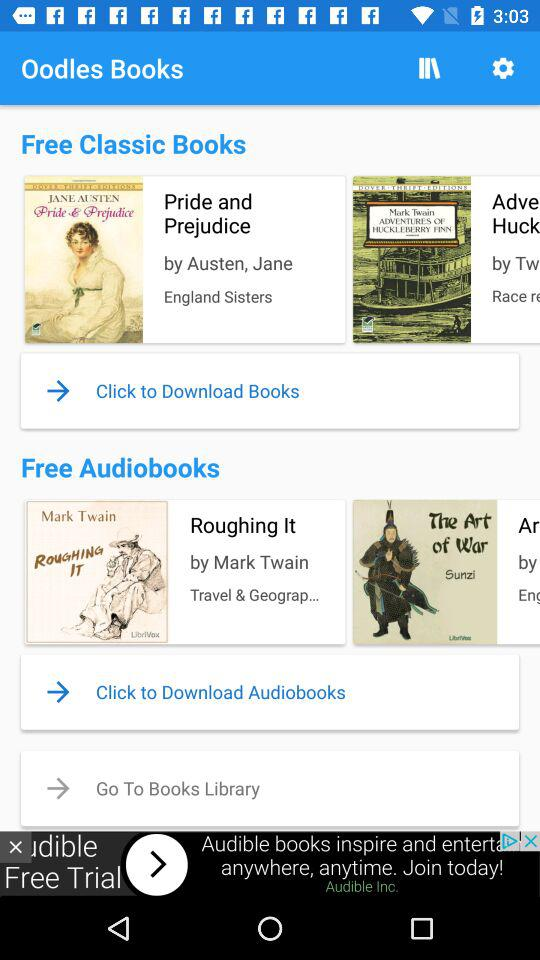How many books are in the free audio books section?
Answer the question using a single word or phrase. 2 